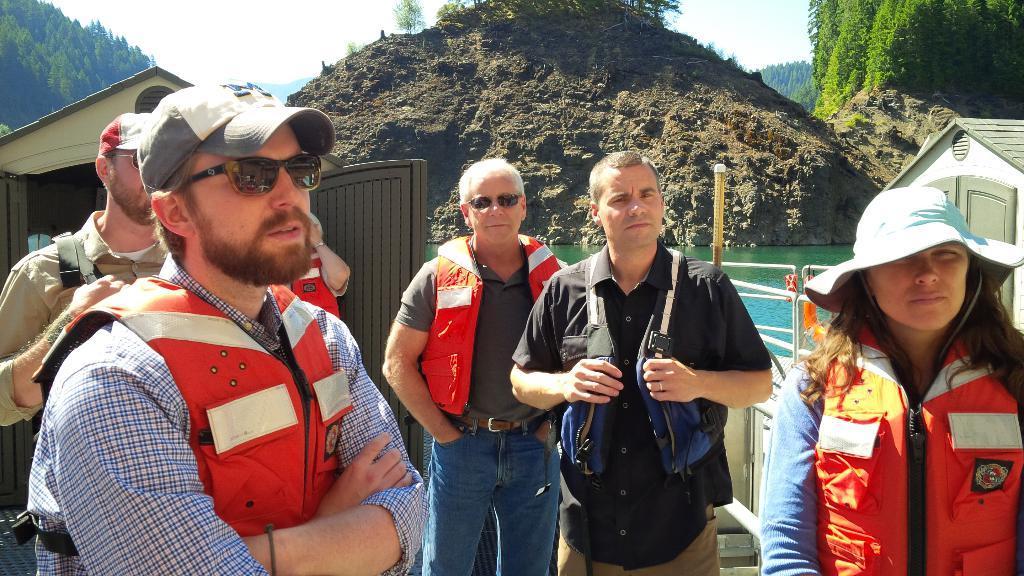Please provide a concise description of this image. In this image I can see few people are standing and I can see all of them are wearing life jackets. On the both sides of this image I can see few persons are wearing caps. On the left side I can see three of them are wearing shades. In the background I can see two shacks, doors, railing, water, number of trees and the sky. 